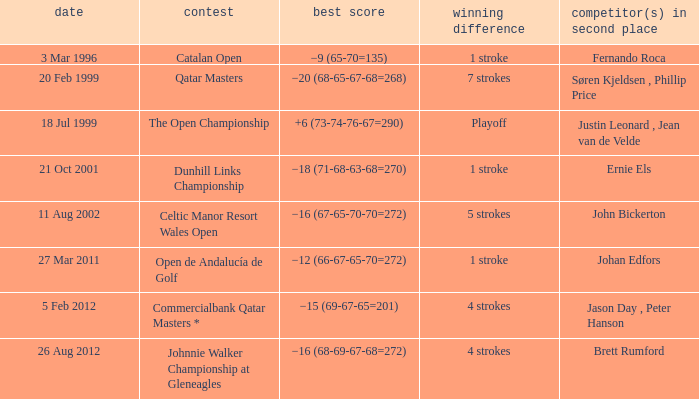What tournament that Fernando Roca is the runner-up? Catalan Open. 